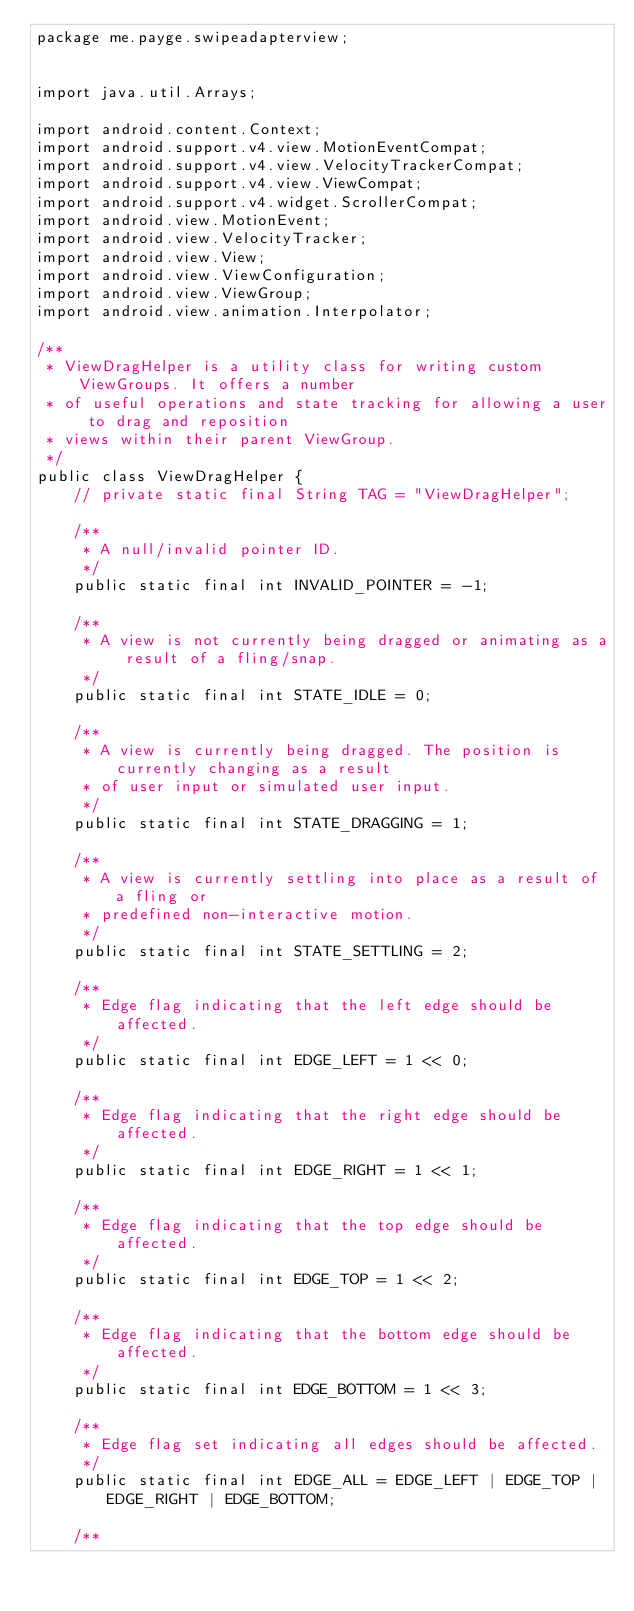Convert code to text. <code><loc_0><loc_0><loc_500><loc_500><_Java_>package me.payge.swipeadapterview;


import java.util.Arrays;

import android.content.Context;
import android.support.v4.view.MotionEventCompat;
import android.support.v4.view.VelocityTrackerCompat;
import android.support.v4.view.ViewCompat;
import android.support.v4.widget.ScrollerCompat;
import android.view.MotionEvent;
import android.view.VelocityTracker;
import android.view.View;
import android.view.ViewConfiguration;
import android.view.ViewGroup;
import android.view.animation.Interpolator;

/**
 * ViewDragHelper is a utility class for writing custom ViewGroups. It offers a number
 * of useful operations and state tracking for allowing a user to drag and reposition
 * views within their parent ViewGroup.
 */
public class ViewDragHelper {
    // private static final String TAG = "ViewDragHelper";

    /**
     * A null/invalid pointer ID.
     */
    public static final int INVALID_POINTER = -1;

    /**
     * A view is not currently being dragged or animating as a result of a fling/snap.
     */
    public static final int STATE_IDLE = 0;

    /**
     * A view is currently being dragged. The position is currently changing as a result
     * of user input or simulated user input.
     */
    public static final int STATE_DRAGGING = 1;

    /**
     * A view is currently settling into place as a result of a fling or
     * predefined non-interactive motion.
     */
    public static final int STATE_SETTLING = 2;

    /**
     * Edge flag indicating that the left edge should be affected.
     */
    public static final int EDGE_LEFT = 1 << 0;

    /**
     * Edge flag indicating that the right edge should be affected.
     */
    public static final int EDGE_RIGHT = 1 << 1;

    /**
     * Edge flag indicating that the top edge should be affected.
     */
    public static final int EDGE_TOP = 1 << 2;

    /**
     * Edge flag indicating that the bottom edge should be affected.
     */
    public static final int EDGE_BOTTOM = 1 << 3;

    /**
     * Edge flag set indicating all edges should be affected.
     */
    public static final int EDGE_ALL = EDGE_LEFT | EDGE_TOP | EDGE_RIGHT | EDGE_BOTTOM;

    /**</code> 